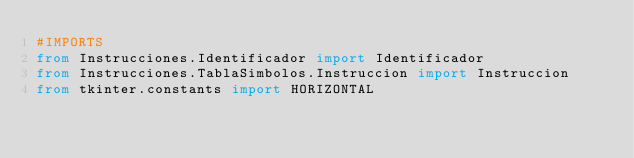Convert code to text. <code><loc_0><loc_0><loc_500><loc_500><_Python_>#IMPORTS
from Instrucciones.Identificador import Identificador
from Instrucciones.TablaSimbolos.Instruccion import Instruccion
from tkinter.constants import HORIZONTAL</code> 